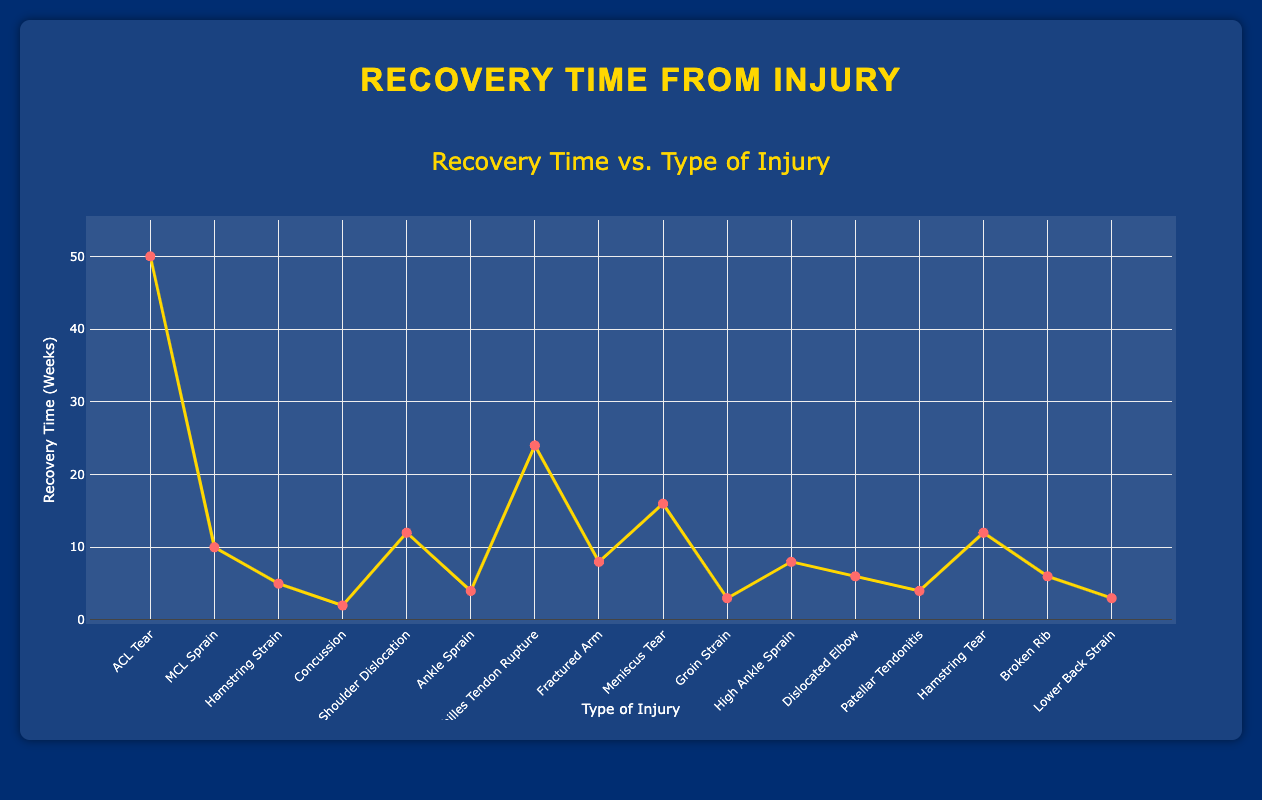What's the injury with the longest recovery time? By examining the plot, identify the point on the graph that is the highest on the y-axis. This corresponds to the injury with the longest recovery time.
Answer: ACL Tear What's the average recovery time across all injuries? Add all the recovery times together: 50 + 10 + 5 + 2 + 12 + 4 + 24 + 8 + 16 + 3 + 8 + 6 + 4 + 12 + 6 + 3, which equals 173. Then, divide by the number of injuries, which is 16. So, the average is 173 / 16.
Answer: 10.81 weeks Which injuries have a recovery time of fewer than 5 weeks? Look at the points on the graph that are below the y-value of 5 weeks. These points represent Concussion, Ankle Sprain, Groin Strain, and Lower Back Strain.
Answer: Concussion, Ankle Sprain, Groin Strain, Lower Back Strain Compare the recovery times for MCL Sprain and Meniscus Tear. Which is longer? Locate the points for MCL Sprain and Meniscus Tear on the graph. The y-axis value for MCL Sprain is 10 weeks, and for Meniscus Tear, it is 16 weeks. Therefore, the recovery time for Meniscus Tear is longer.
Answer: Meniscus Tear What is the total recovery time for Concussion, Ankle Sprain, and Broken Rib combined? Add the recovery times for Concussion (2 weeks), Ankle Sprain (4 weeks), and Broken Rib (6 weeks). So, 2 + 4 + 6 = 12 weeks.
Answer: 12 weeks Which type of injury has a recovery time equal to 12 weeks? Look for the point on the graph where the y-axis value is 12 weeks. There are two such points: Shoulder Dislocation and Hamstring Tear.
Answer: Shoulder Dislocation, Hamstring Tear What is the difference in recovery time between ACL Tear and Hamstring Strain? Find the recovery times for ACL Tear (50 weeks) and Hamstring Strain (5 weeks). Subtract the smaller number from the larger one: 50 - 5 = 45 weeks.
Answer: 45 weeks Which injury types have a recovery time of 6 weeks? Identify the points on the graph where the y-axis value equals 6 weeks. These points represent Dislocated Elbow and Broken Rib.
Answer: Dislocated Elbow, Broken Rib Identify the injury with a recovery time of 24 weeks. Find the point on the graph where the y-axis value is 24 weeks. This corresponds to Achilles Tendon Rupture.
Answer: Achilles Tendon Rupture 